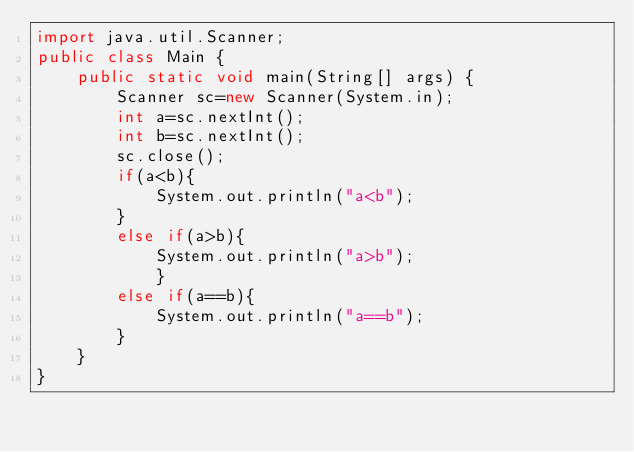<code> <loc_0><loc_0><loc_500><loc_500><_Java_>import java.util.Scanner;
public class Main {
	public static void main(String[] args) {
		Scanner sc=new Scanner(System.in);
	    int a=sc.nextInt();
	    int b=sc.nextInt();
	    sc.close();
	    if(a<b){
	    	System.out.println("a<b");
	    }
	    else if(a>b){
	    	System.out.println("a>b");
	    	}
	    else if(a==b){
	    	System.out.println("a==b");
	    }
	}
}</code> 